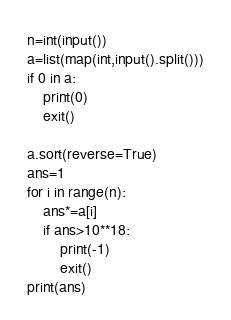<code> <loc_0><loc_0><loc_500><loc_500><_Python_>n=int(input())
a=list(map(int,input().split()))
if 0 in a:
    print(0)
    exit()

a.sort(reverse=True)
ans=1
for i in range(n):
    ans*=a[i]
    if ans>10**18:
        print(-1)
        exit()
print(ans)
</code> 